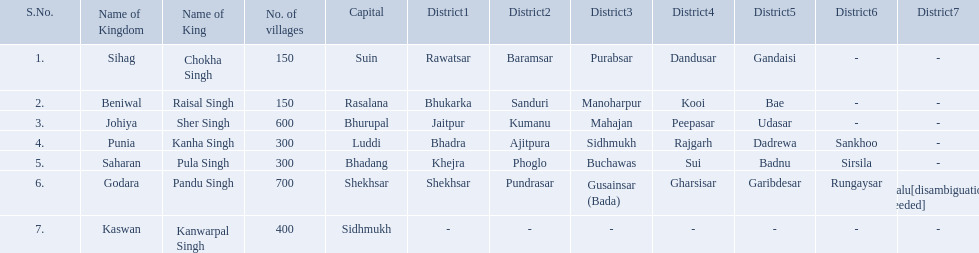Which kingdom contained the least amount of villages along with sihag? Beniwal. Which kingdom contained the most villages? Godara. Which village was tied at second most villages with godara? Johiya. 